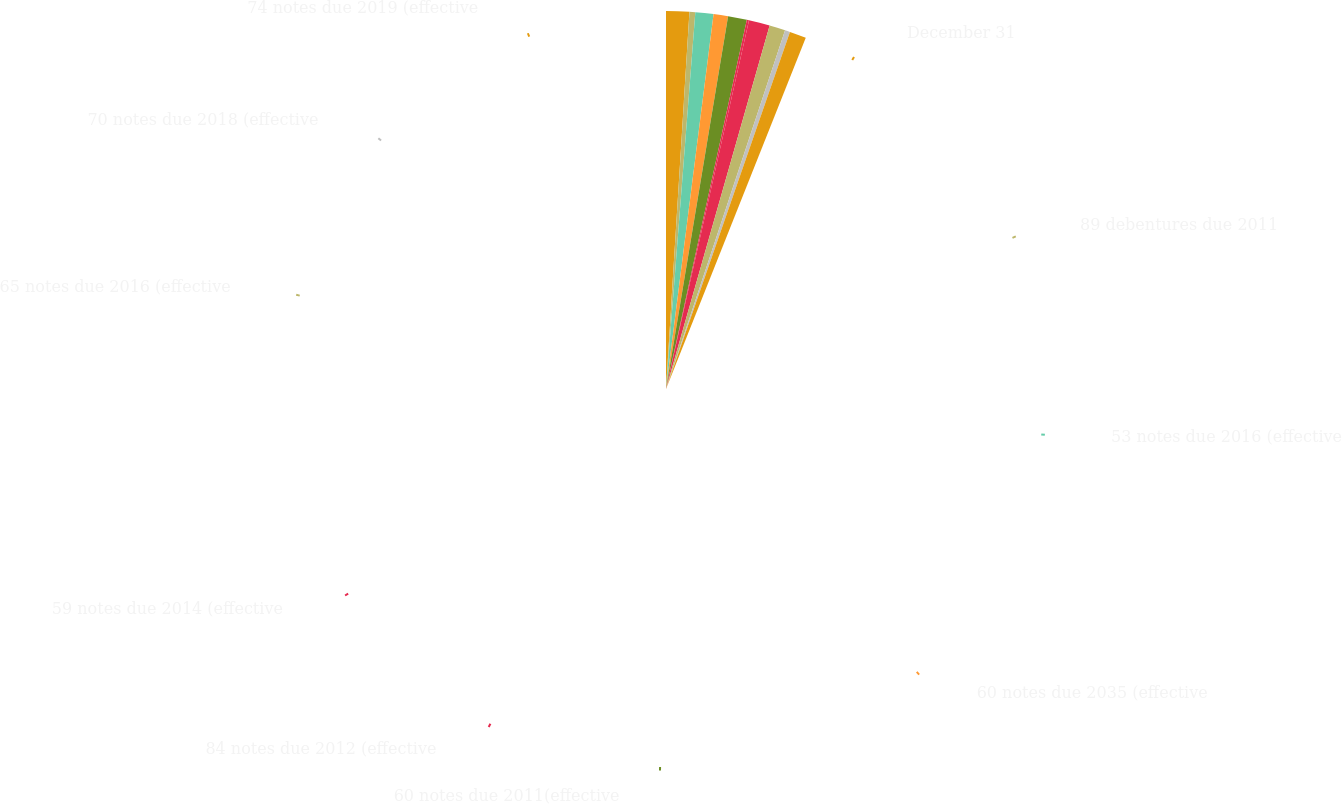Convert chart. <chart><loc_0><loc_0><loc_500><loc_500><pie_chart><fcel>December 31<fcel>89 debentures due 2011<fcel>53 notes due 2016 (effective<fcel>60 notes due 2035 (effective<fcel>60 notes due 2011(effective<fcel>84 notes due 2012 (effective<fcel>59 notes due 2014 (effective<fcel>65 notes due 2016 (effective<fcel>70 notes due 2018 (effective<fcel>74 notes due 2019 (effective<nl><fcel>16.4%<fcel>4.11%<fcel>12.82%<fcel>10.26%<fcel>13.33%<fcel>1.55%<fcel>14.87%<fcel>11.28%<fcel>3.6%<fcel>11.79%<nl></chart> 